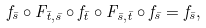<formula> <loc_0><loc_0><loc_500><loc_500>f _ { \bar { s } } \circ F _ { \bar { t } , \bar { s } } \circ f _ { \bar { t } } \circ F _ { \bar { s } , \bar { t } } \circ f _ { \bar { s } } = f _ { \bar { s } } ,</formula> 